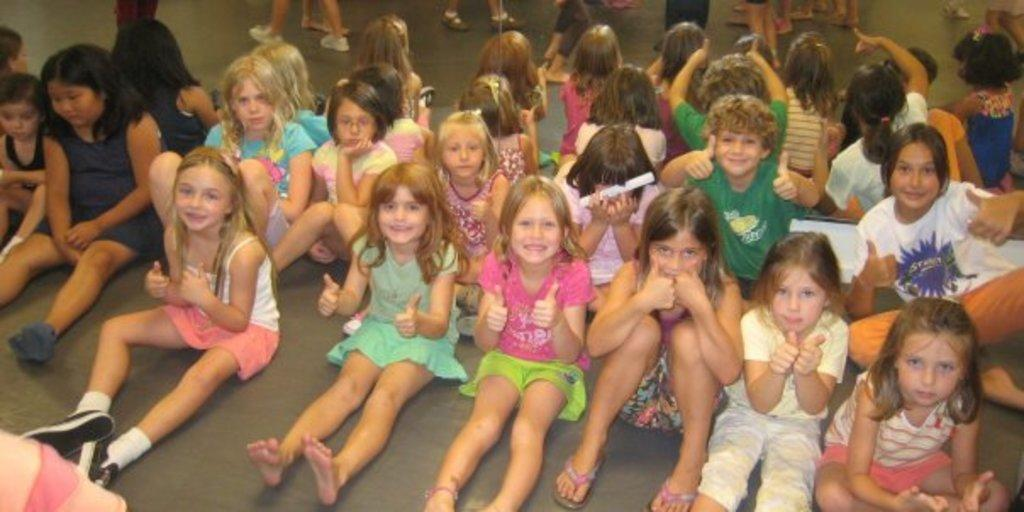How many people are in the image? There are persons in the image, but the exact number is not specified. What can be seen in the background of the image? There is a background with other objects in the image. What is visible at the bottom of the image? The floor is visible at the bottom of the image. What type of bead is being used to clean the floor in the image? There is no bead present in the image, and the floor is not being cleaned. How does the dog interact with the persons in the image? There is no dog present in the image. 